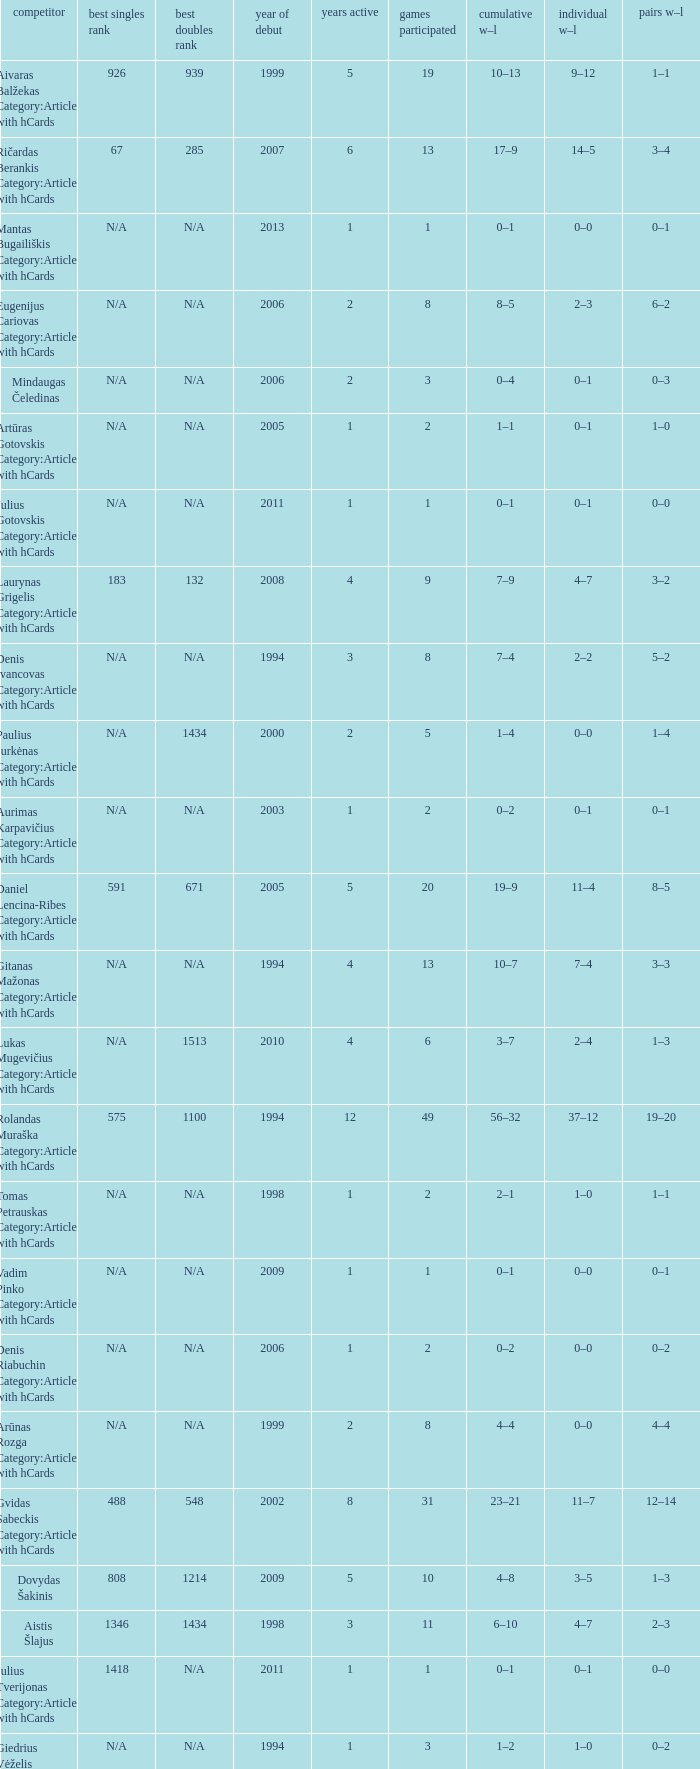Name the minimum tiesplayed for 6 years 13.0. 